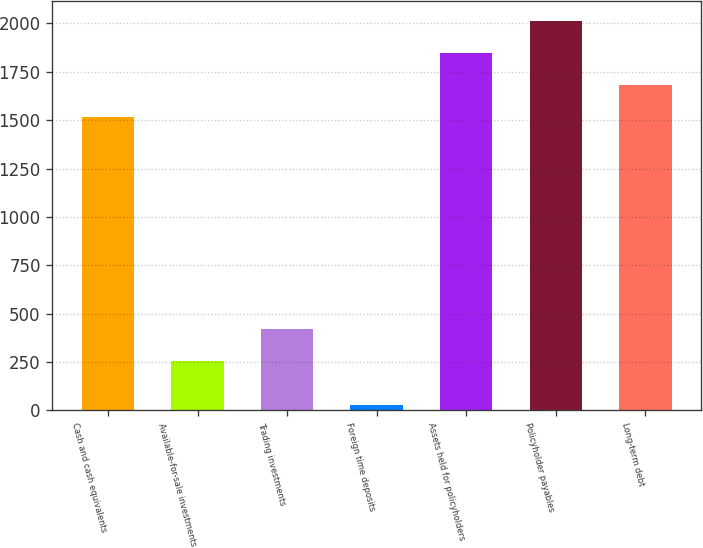Convert chart. <chart><loc_0><loc_0><loc_500><loc_500><bar_chart><fcel>Cash and cash equivalents<fcel>Available-for-sale investments<fcel>Trading investments<fcel>Foreign time deposits<fcel>Assets held for policyholders<fcel>Policyholder payables<fcel>Long-term debt<nl><fcel>1514.2<fcel>255.9<fcel>422.73<fcel>29.6<fcel>1847.86<fcel>2014.69<fcel>1681.03<nl></chart> 